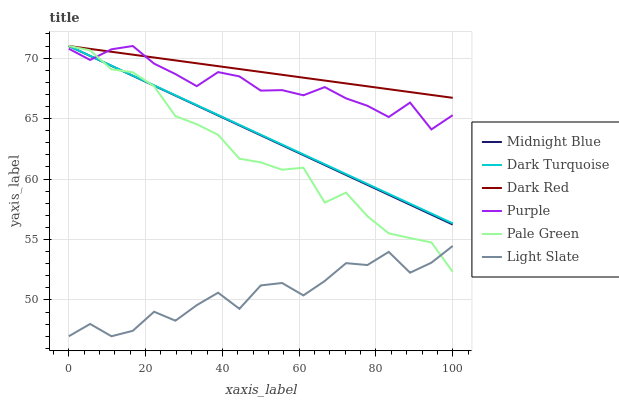Does Light Slate have the minimum area under the curve?
Answer yes or no. Yes. Does Dark Red have the maximum area under the curve?
Answer yes or no. Yes. Does Purple have the minimum area under the curve?
Answer yes or no. No. Does Purple have the maximum area under the curve?
Answer yes or no. No. Is Dark Red the smoothest?
Answer yes or no. Yes. Is Light Slate the roughest?
Answer yes or no. Yes. Is Purple the smoothest?
Answer yes or no. No. Is Purple the roughest?
Answer yes or no. No. Does Light Slate have the lowest value?
Answer yes or no. Yes. Does Purple have the lowest value?
Answer yes or no. No. Does Dark Red have the highest value?
Answer yes or no. Yes. Does Light Slate have the highest value?
Answer yes or no. No. Is Light Slate less than Midnight Blue?
Answer yes or no. Yes. Is Dark Red greater than Light Slate?
Answer yes or no. Yes. Does Pale Green intersect Light Slate?
Answer yes or no. Yes. Is Pale Green less than Light Slate?
Answer yes or no. No. Is Pale Green greater than Light Slate?
Answer yes or no. No. Does Light Slate intersect Midnight Blue?
Answer yes or no. No. 